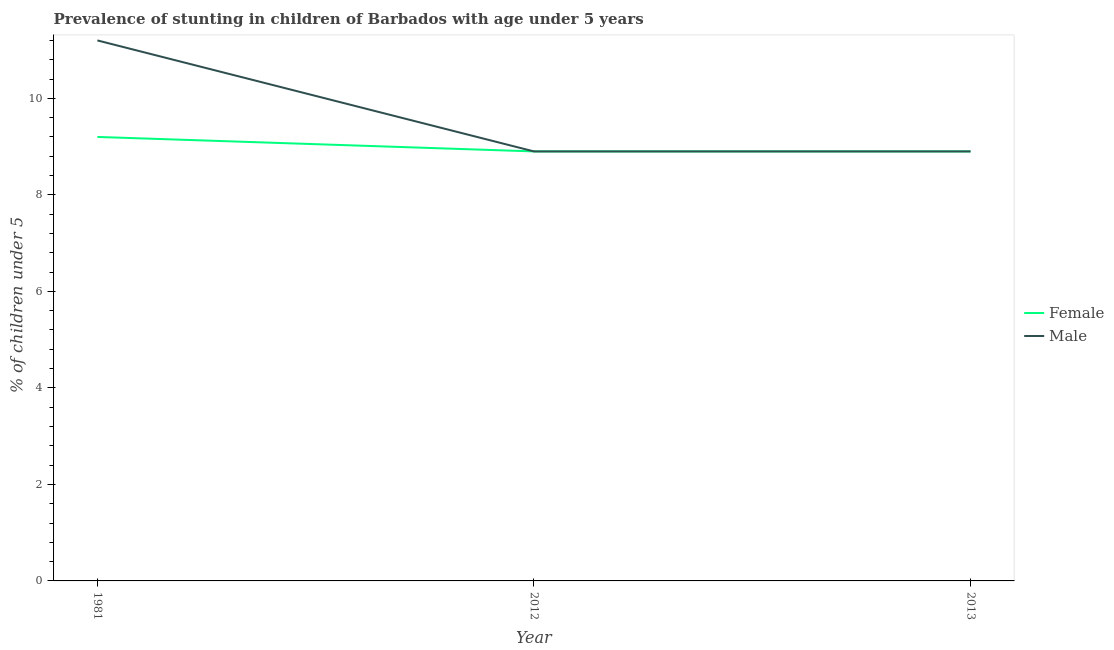Does the line corresponding to percentage of stunted female children intersect with the line corresponding to percentage of stunted male children?
Provide a succinct answer. Yes. Is the number of lines equal to the number of legend labels?
Offer a terse response. Yes. Across all years, what is the maximum percentage of stunted male children?
Ensure brevity in your answer.  11.2. Across all years, what is the minimum percentage of stunted male children?
Ensure brevity in your answer.  8.9. In which year was the percentage of stunted male children maximum?
Your answer should be compact. 1981. What is the total percentage of stunted female children in the graph?
Your response must be concise. 27. What is the difference between the percentage of stunted female children in 1981 and that in 2013?
Make the answer very short. 0.3. What is the difference between the percentage of stunted male children in 2012 and the percentage of stunted female children in 2013?
Keep it short and to the point. -3.8146973047048505e-7. What is the average percentage of stunted male children per year?
Your answer should be compact. 9.67. In the year 2012, what is the difference between the percentage of stunted male children and percentage of stunted female children?
Your answer should be compact. 0. What is the ratio of the percentage of stunted female children in 1981 to that in 2013?
Ensure brevity in your answer.  1.03. Is the difference between the percentage of stunted male children in 1981 and 2012 greater than the difference between the percentage of stunted female children in 1981 and 2012?
Offer a very short reply. Yes. What is the difference between the highest and the second highest percentage of stunted female children?
Provide a short and direct response. 0.3. What is the difference between the highest and the lowest percentage of stunted male children?
Provide a short and direct response. 2.3. Does the percentage of stunted female children monotonically increase over the years?
Ensure brevity in your answer.  No. Is the percentage of stunted male children strictly greater than the percentage of stunted female children over the years?
Ensure brevity in your answer.  No. Is the percentage of stunted male children strictly less than the percentage of stunted female children over the years?
Offer a terse response. No. How many lines are there?
Give a very brief answer. 2. How many years are there in the graph?
Offer a very short reply. 3. Are the values on the major ticks of Y-axis written in scientific E-notation?
Ensure brevity in your answer.  No. Does the graph contain any zero values?
Provide a short and direct response. No. How many legend labels are there?
Keep it short and to the point. 2. How are the legend labels stacked?
Give a very brief answer. Vertical. What is the title of the graph?
Offer a very short reply. Prevalence of stunting in children of Barbados with age under 5 years. What is the label or title of the X-axis?
Make the answer very short. Year. What is the label or title of the Y-axis?
Give a very brief answer.  % of children under 5. What is the  % of children under 5 of Female in 1981?
Offer a very short reply. 9.2. What is the  % of children under 5 in Male in 1981?
Provide a short and direct response. 11.2. What is the  % of children under 5 of Female in 2012?
Provide a short and direct response. 8.9. What is the  % of children under 5 in Male in 2012?
Offer a terse response. 8.9. What is the  % of children under 5 in Female in 2013?
Give a very brief answer. 8.9. Across all years, what is the maximum  % of children under 5 in Female?
Your response must be concise. 9.2. Across all years, what is the maximum  % of children under 5 in Male?
Make the answer very short. 11.2. Across all years, what is the minimum  % of children under 5 in Female?
Keep it short and to the point. 8.9. Across all years, what is the minimum  % of children under 5 in Male?
Provide a succinct answer. 8.9. What is the total  % of children under 5 of Male in the graph?
Offer a very short reply. 29. What is the difference between the  % of children under 5 in Female in 1981 and that in 2012?
Keep it short and to the point. 0.3. What is the difference between the  % of children under 5 of Male in 1981 and that in 2013?
Provide a succinct answer. 2.3. What is the difference between the  % of children under 5 of Female in 2012 and that in 2013?
Ensure brevity in your answer.  -0. What is the difference between the  % of children under 5 in Female in 1981 and the  % of children under 5 in Male in 2012?
Ensure brevity in your answer.  0.3. What is the average  % of children under 5 of Male per year?
Offer a terse response. 9.67. What is the ratio of the  % of children under 5 in Female in 1981 to that in 2012?
Your answer should be compact. 1.03. What is the ratio of the  % of children under 5 in Male in 1981 to that in 2012?
Offer a terse response. 1.26. What is the ratio of the  % of children under 5 in Female in 1981 to that in 2013?
Offer a terse response. 1.03. What is the ratio of the  % of children under 5 in Male in 1981 to that in 2013?
Give a very brief answer. 1.26. What is the ratio of the  % of children under 5 of Female in 2012 to that in 2013?
Give a very brief answer. 1. What is the ratio of the  % of children under 5 in Male in 2012 to that in 2013?
Provide a short and direct response. 1. What is the difference between the highest and the lowest  % of children under 5 in Female?
Offer a terse response. 0.3. 